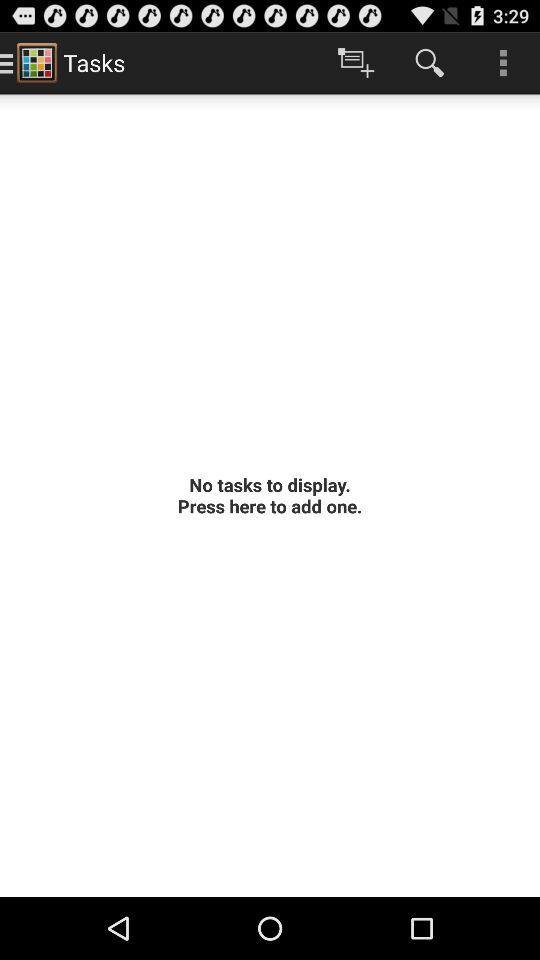Are there any tasks to display? There are no tasks to display. 